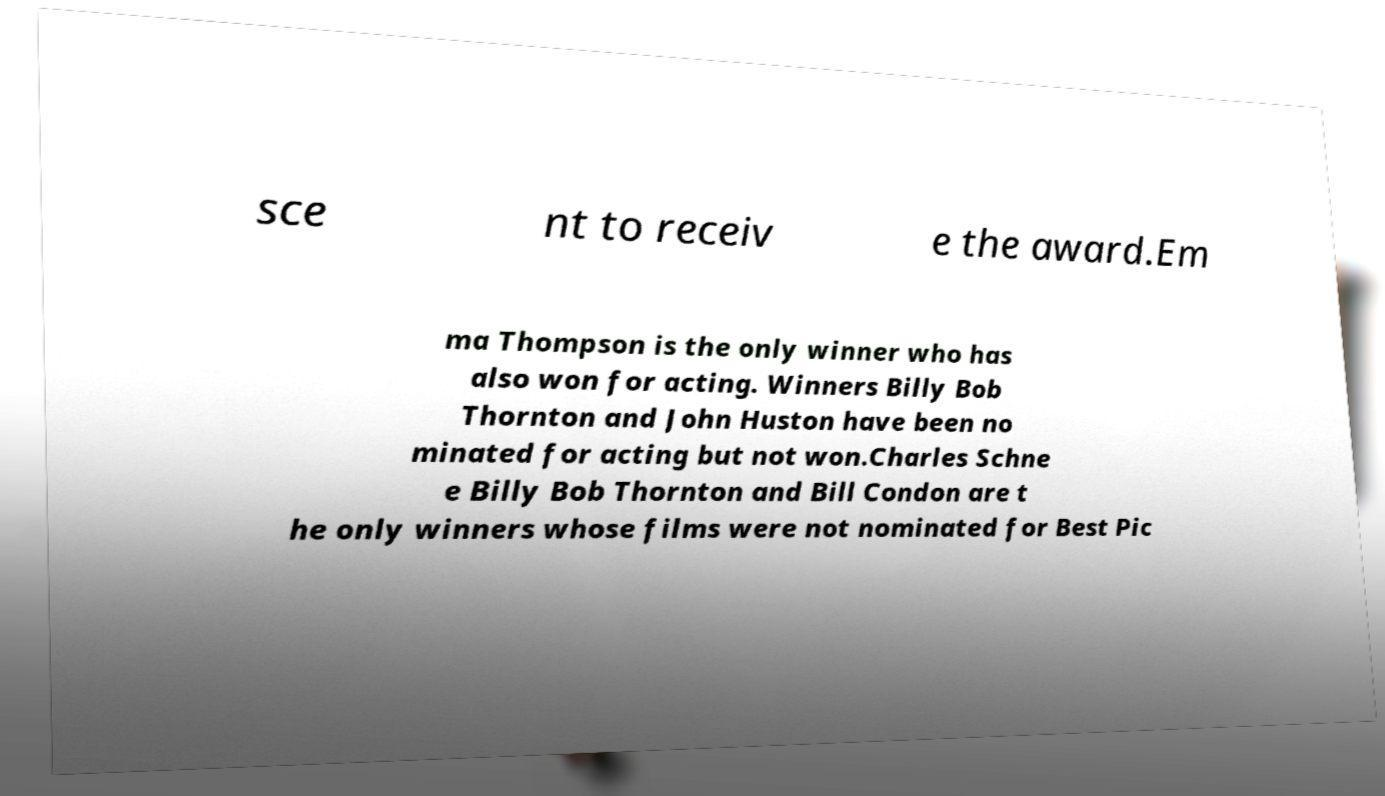Please identify and transcribe the text found in this image. sce nt to receiv e the award.Em ma Thompson is the only winner who has also won for acting. Winners Billy Bob Thornton and John Huston have been no minated for acting but not won.Charles Schne e Billy Bob Thornton and Bill Condon are t he only winners whose films were not nominated for Best Pic 